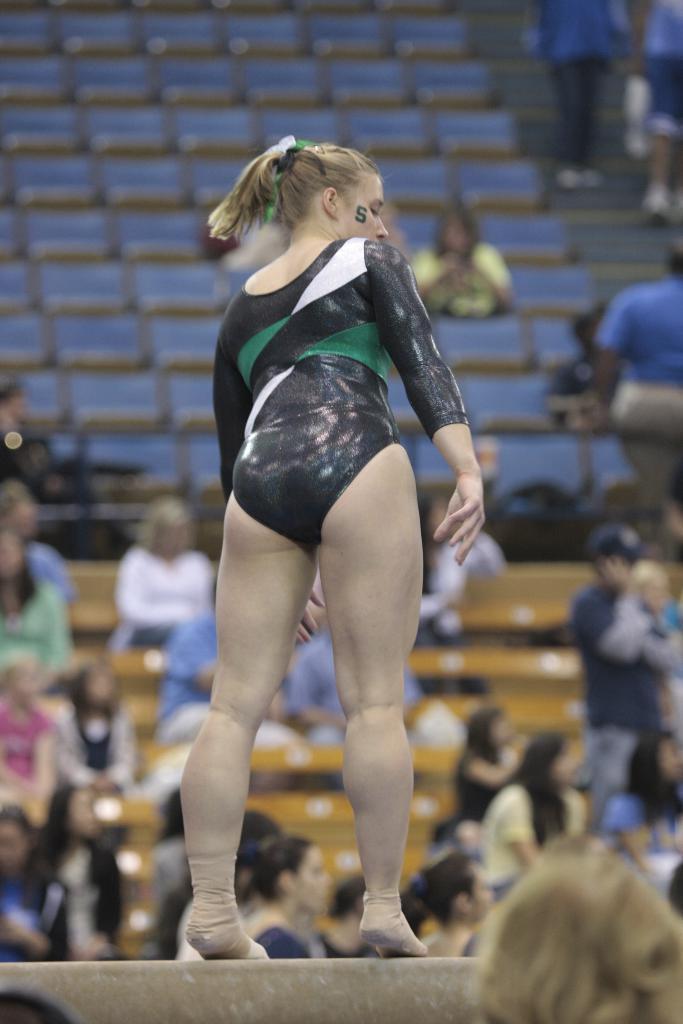Please provide a concise description of this image. In this image we can see a woman standing on the balance beam. On the backside we can see a group of people sitting on the chairs and some people standing on the stairs. On the bottom of the image we can see the head of a person. 